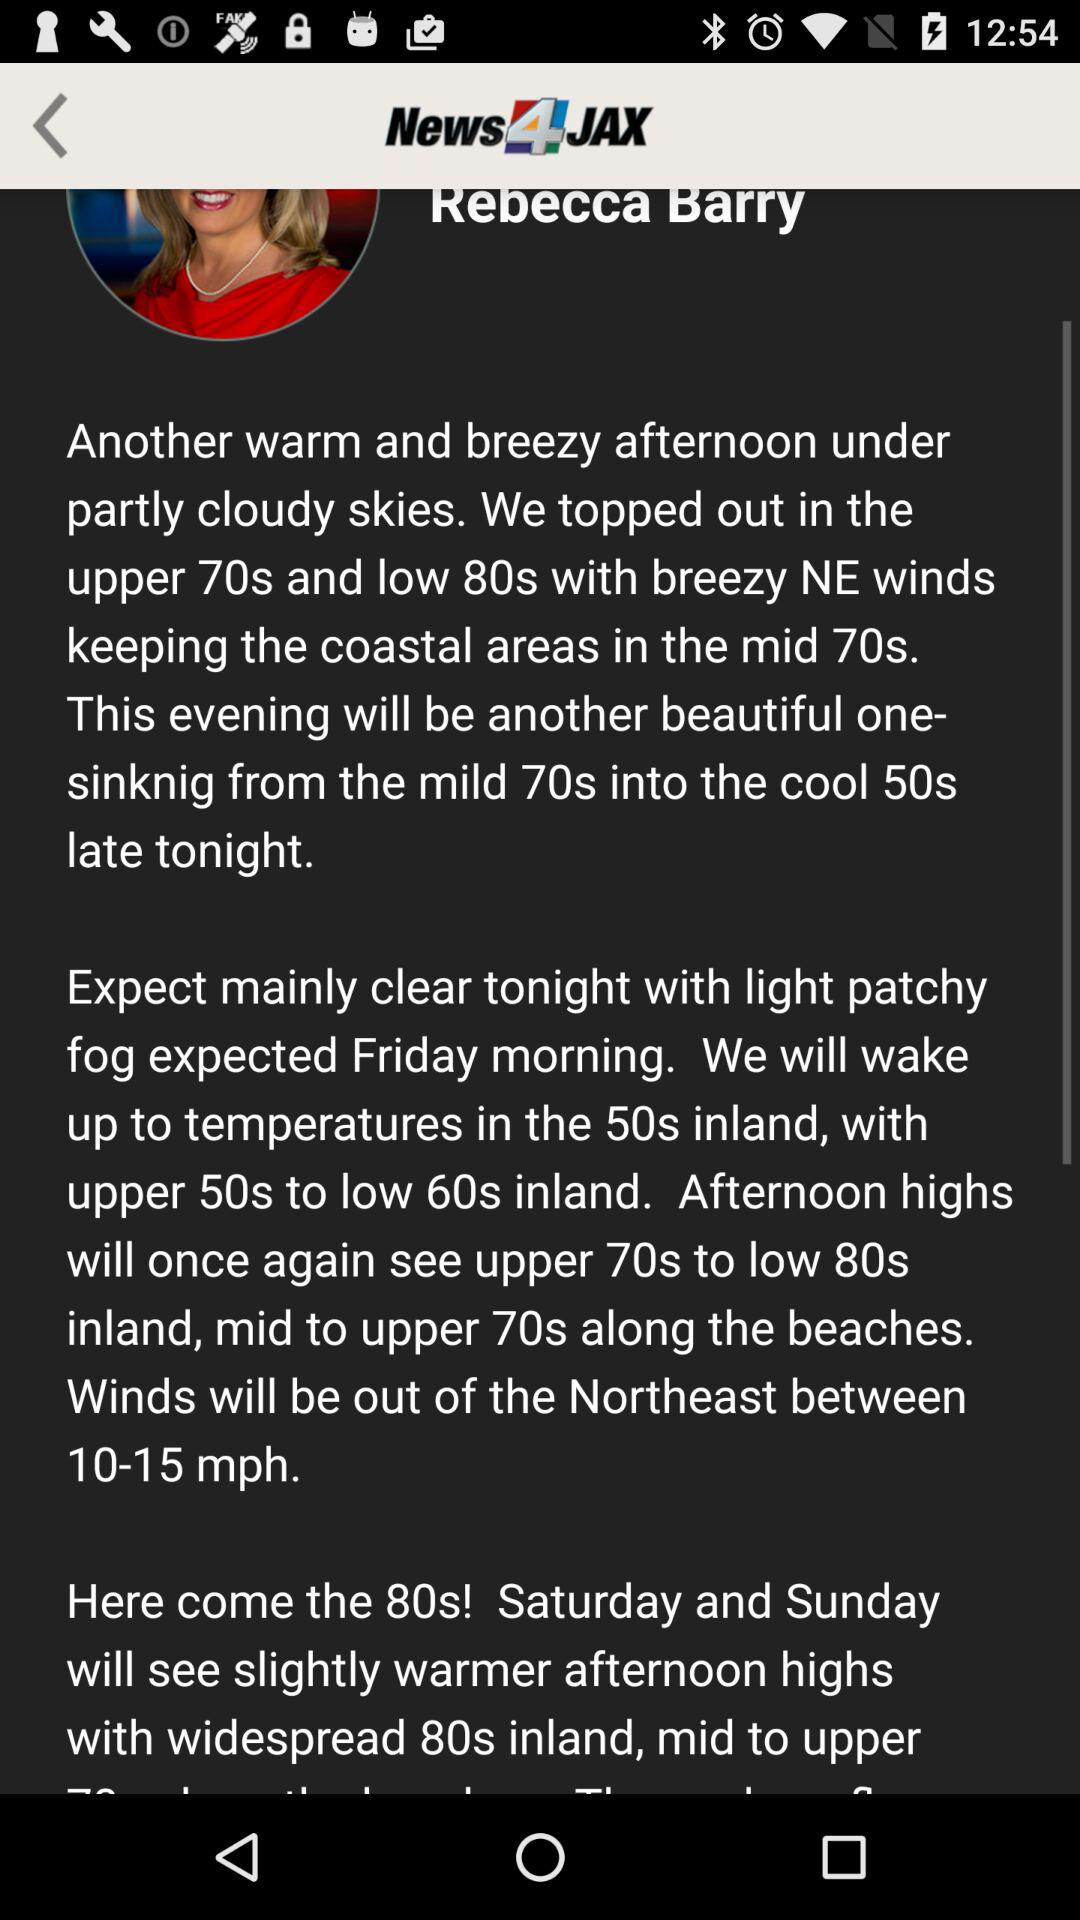How many degrees cooler will it be tonight compared to this afternoon?
Answer the question using a single word or phrase. 20 